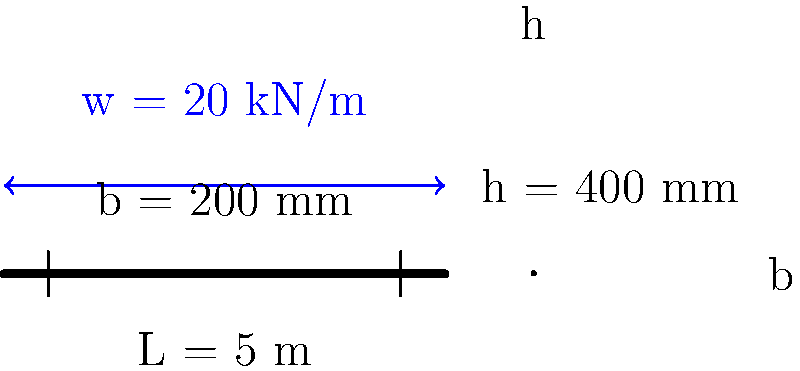A simply supported rectangular concrete beam has a span of 5 m, width of 200 mm, and depth of 400 mm. It is subjected to a uniformly distributed load of 20 kN/m along its entire length. The concrete has a characteristic compressive strength ($f_{ck}$) of 30 MPa and a partial safety factor ($\gamma_c$) of 1.5. Calculate the maximum bending moment in the beam and determine if the beam can safely resist this moment, assuming the effective depth (d) is 0.9 times the total depth. Use the simplified rectangular stress block method for concrete design with $\lambda = 0.8$ and $\eta = 1.0$. Step 1: Calculate the maximum bending moment
The maximum bending moment for a simply supported beam with uniformly distributed load occurs at the center:
$M_{max} = \frac{wL^2}{8} = \frac{20 \times 5^2}{8} = 62.5$ kN⋅m

Step 2: Calculate the effective depth (d)
$d = 0.9h = 0.9 \times 400 = 360$ mm

Step 3: Calculate the design strength of concrete
$f_{cd} = \frac{f_{ck}}{\gamma_c} = \frac{30}{1.5} = 20$ MPa

Step 4: Calculate the lever arm (z)
Assume $z = 0.9d = 0.9 \times 360 = 324$ mm

Step 5: Calculate the maximum moment capacity of the section
$M_{Rd} = \eta f_{cd} b \lambda x (d - 0.5\lambda x)$
where $x$ is the neutral axis depth.

Assuming the neutral axis depth is less than the flange thickness:
$x = \frac{M_{Rd}}{\eta f_{cd} b \lambda (d - 0.5\lambda x)}$

Substituting the known values:
$62.5 \times 10^6 = 1.0 \times 20 \times 200 \times 0.8x(360 - 0.4x)$

Solving this quadratic equation:
$x = 54.7$ mm

Verify the assumption: $x < b$, so the assumption is correct.

Step 6: Calculate the actual moment capacity
$M_{Rd} = 1.0 \times 20 \times 200 \times 0.8 \times 54.7 \times (360 - 0.4 \times 54.7) \times 10^{-6}$
$M_{Rd} = 73.4$ kN⋅m

Step 7: Check if the beam can safely resist the applied moment
$M_{Rd} = 73.4$ kN⋅m > $M_{max} = 62.5$ kN⋅m

Therefore, the beam can safely resist the applied moment.
Answer: Yes, the beam can safely resist the maximum bending moment of 62.5 kN⋅m, as its moment capacity (73.4 kN⋅m) exceeds the applied moment. 